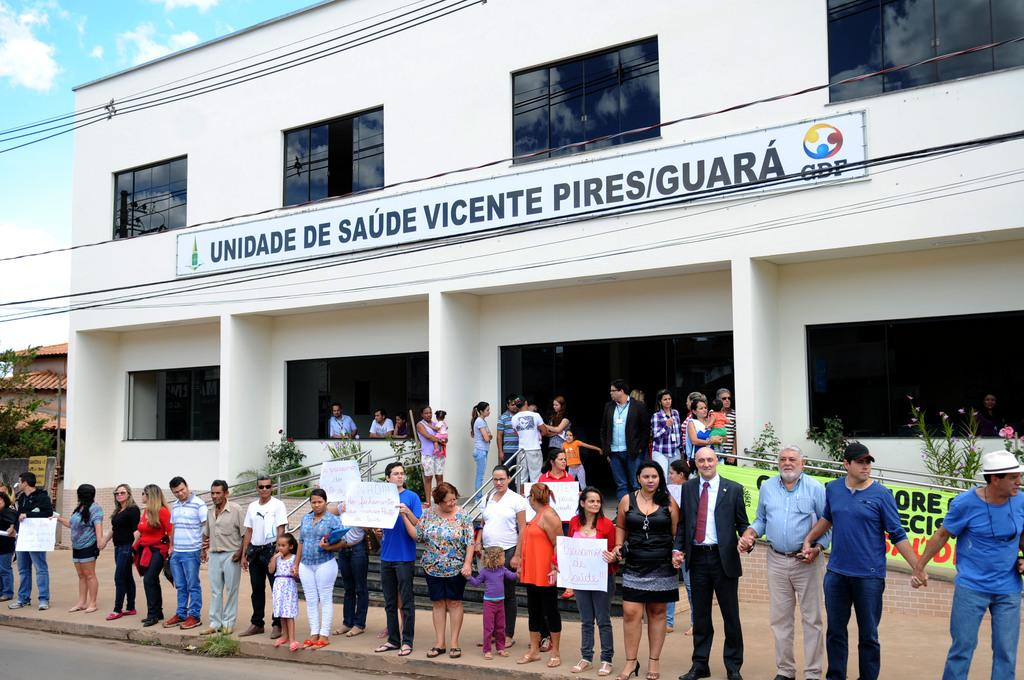What is the main structure in the center of the image? There is a building in the center of the image. What are the people at the bottom of the image doing? The people are standing at the bottom of the image, holding boards. What type of natural vegetation can be seen in the image? There are trees visible in the image. What else is present in the image besides the building and trees? Wires are present in the image. What is visible at the top of the image? The sky is visible at the top of the image. How many clams can be seen on the building in the image? There are no clams present on the building in the image. What type of wax is used to coat the trees in the image? There is no wax present on the trees in the image. 